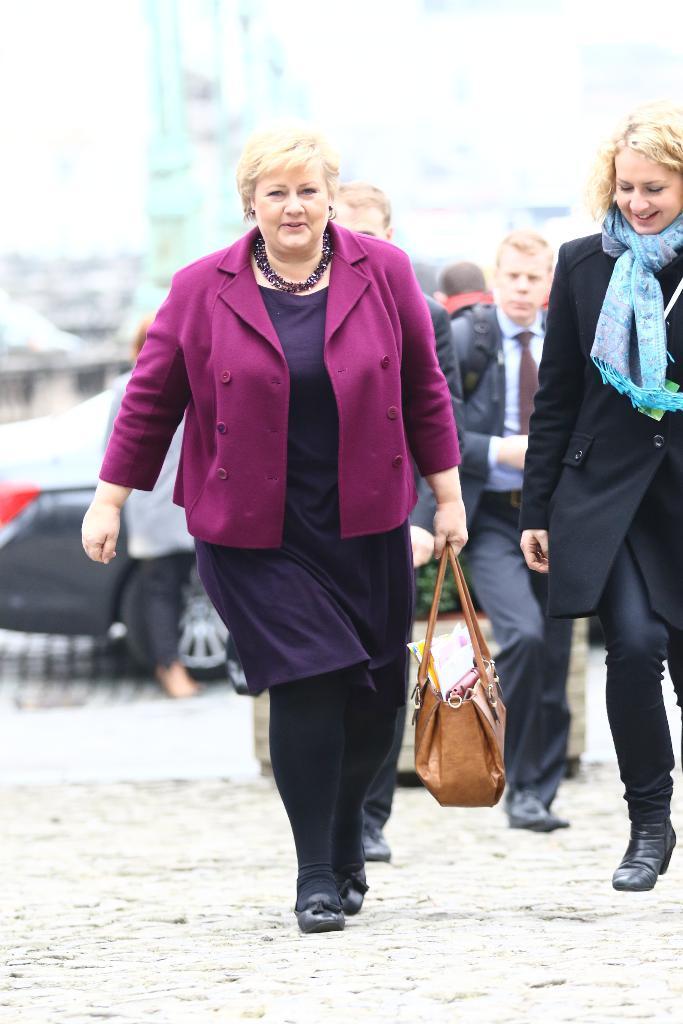Please provide a concise description of this image. In the given picture there is a lady who is walking at the center of the image, by holding a hand bag in her hand and there is another lady at the right side of the image, it seems to be a street view and there is a car behind them. 